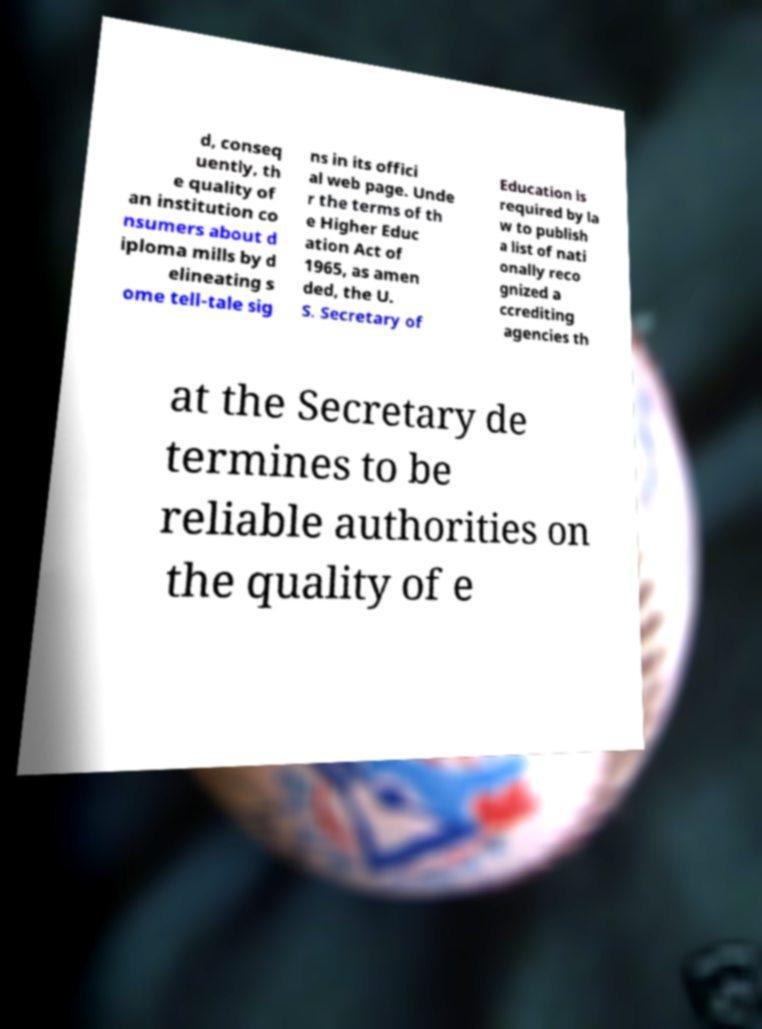For documentation purposes, I need the text within this image transcribed. Could you provide that? d, conseq uently, th e quality of an institution co nsumers about d iploma mills by d elineating s ome tell-tale sig ns in its offici al web page. Unde r the terms of th e Higher Educ ation Act of 1965, as amen ded, the U. S. Secretary of Education is required by la w to publish a list of nati onally reco gnized a ccrediting agencies th at the Secretary de termines to be reliable authorities on the quality of e 